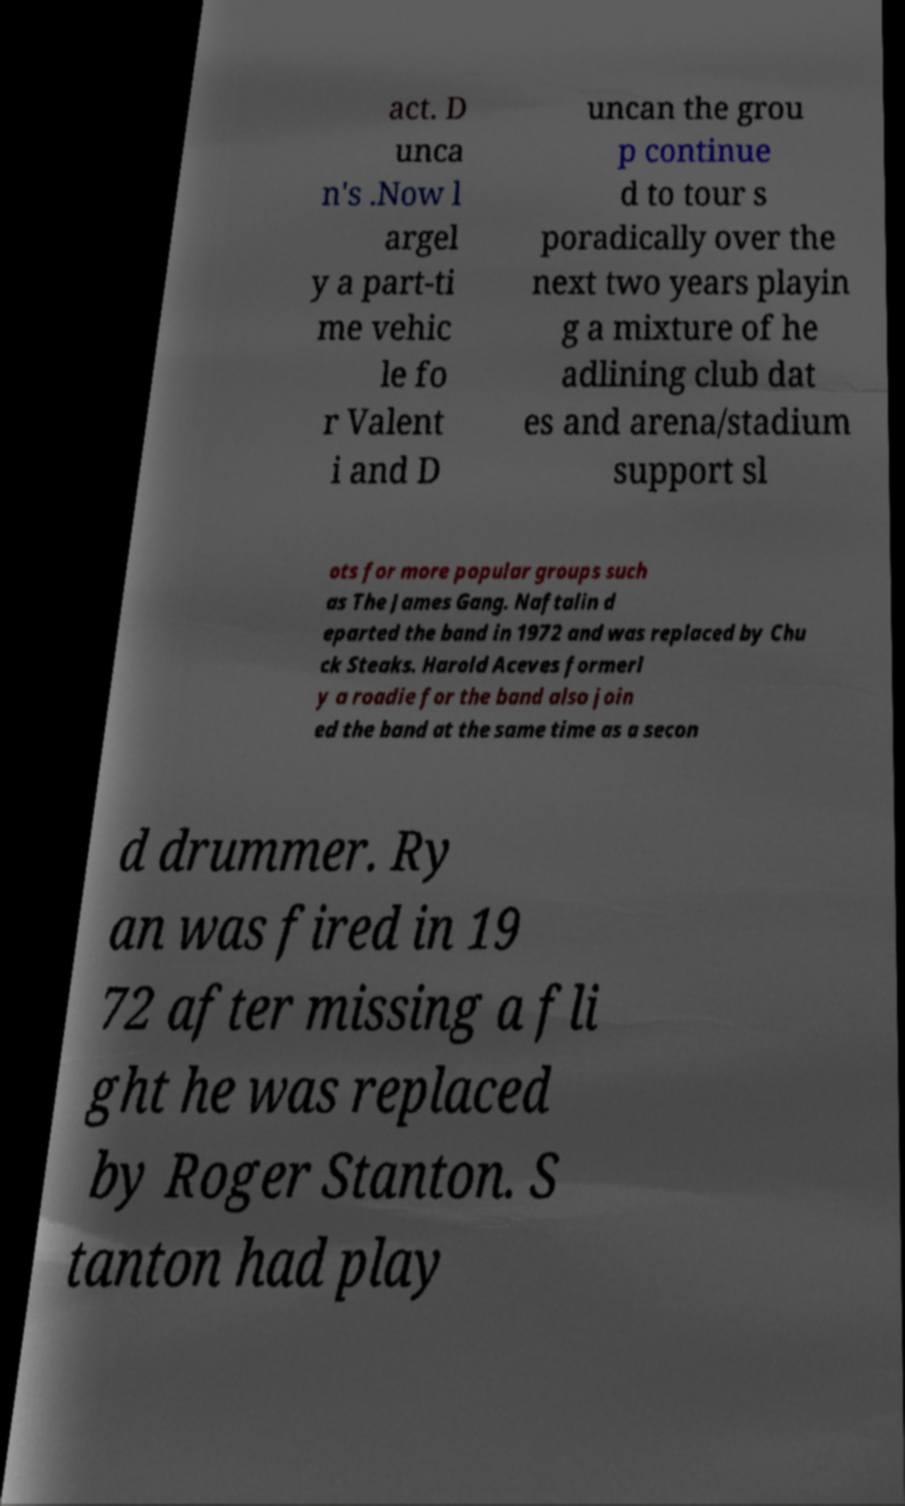Please identify and transcribe the text found in this image. act. D unca n's .Now l argel y a part-ti me vehic le fo r Valent i and D uncan the grou p continue d to tour s poradically over the next two years playin g a mixture of he adlining club dat es and arena/stadium support sl ots for more popular groups such as The James Gang. Naftalin d eparted the band in 1972 and was replaced by Chu ck Steaks. Harold Aceves formerl y a roadie for the band also join ed the band at the same time as a secon d drummer. Ry an was fired in 19 72 after missing a fli ght he was replaced by Roger Stanton. S tanton had play 